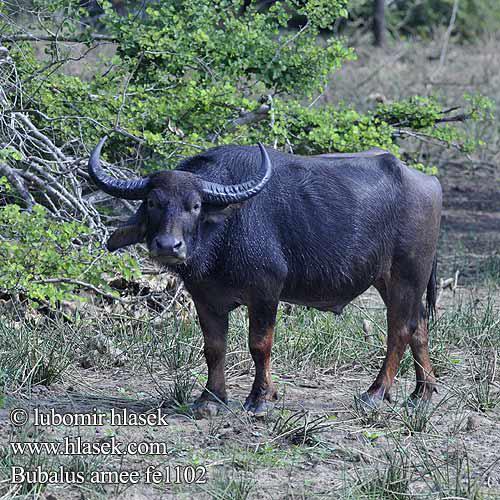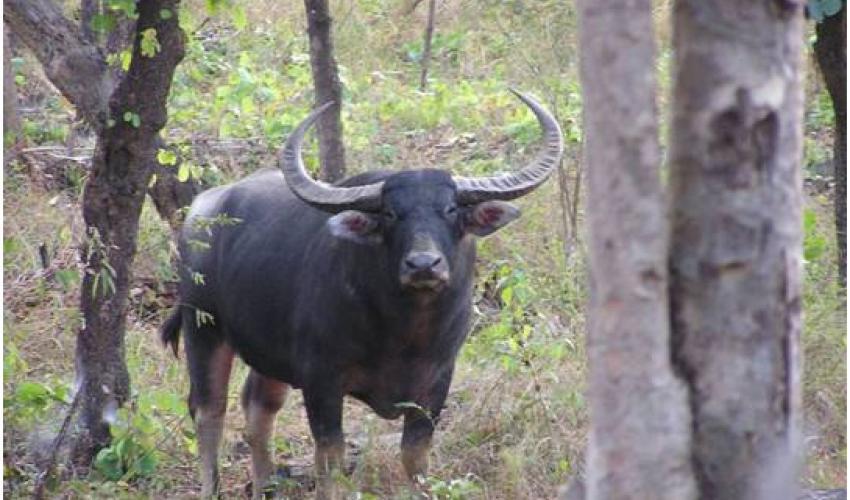The first image is the image on the left, the second image is the image on the right. Given the left and right images, does the statement "Each image contains exactly one horned animal, and the horned animal in the right image has its face turned to the camera." hold true? Answer yes or no. Yes. 